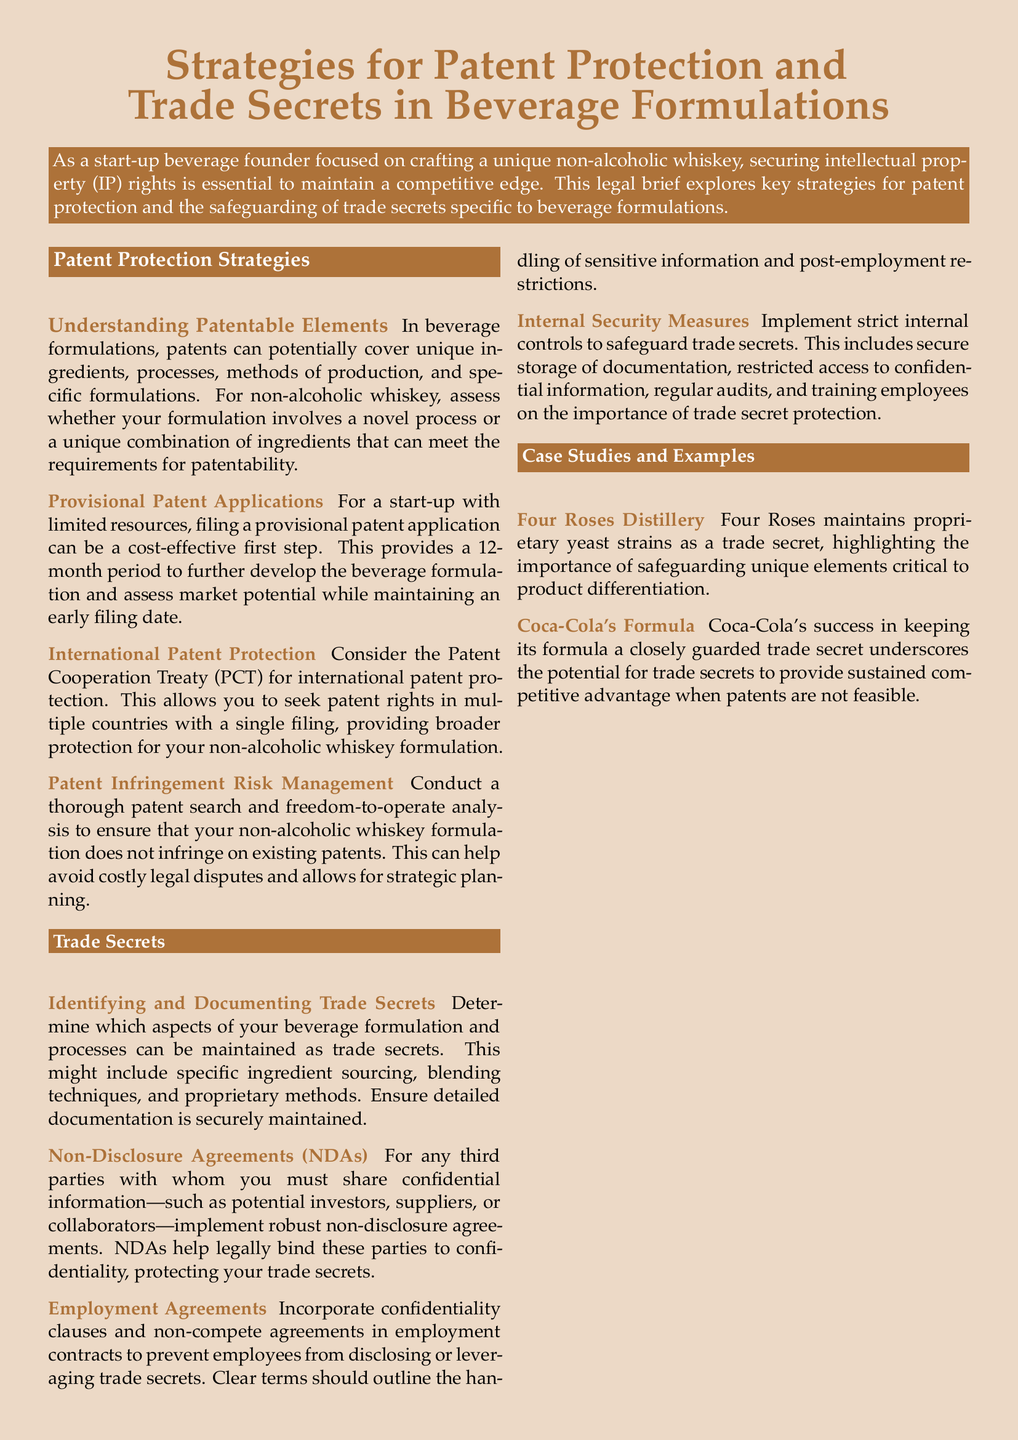What is the title of the legal brief? The title is prominently displayed at the top of the document and reflects the main subject of the content.
Answer: Strategies for Patent Protection and Trade Secrets in Beverage Formulations How long is the provisional patent application period? The document specifies that this period allows for a certain timeframe before further actions need to be taken.
Answer: 12 months What does PCT stand for? PCT is mentioned in the context of international patent protection and stands for a specific treaty.
Answer: Patent Cooperation Treaty Which company is cited as an example of trade secret protection? The document provides an example of a company that successfully maintains trade secrets relevant to their product.
Answer: Coca-Cola What should be included in employment agreements to protect trade secrets? The document outlines specific clauses that should be present to maintain confidentiality within a corporate structure.
Answer: Confidentiality clauses and non-compete agreements What aspect of Four Roses Distillery is highlighted? This detail emphasizes the importance of unique elements in product differentiation in the beverage industry.
Answer: Proprietary yeast strains Why is patent infringement risk management important? The document explains the significance of this practice to avoid negative legal consequences in the development of a beverage formulation.
Answer: To avoid costly legal disputes What type of agreements can help protect trade secrets when sharing information? The document describes a legal tool that binds third parties to confidentiality.
Answer: Non-Disclosure Agreements (NDAs) 